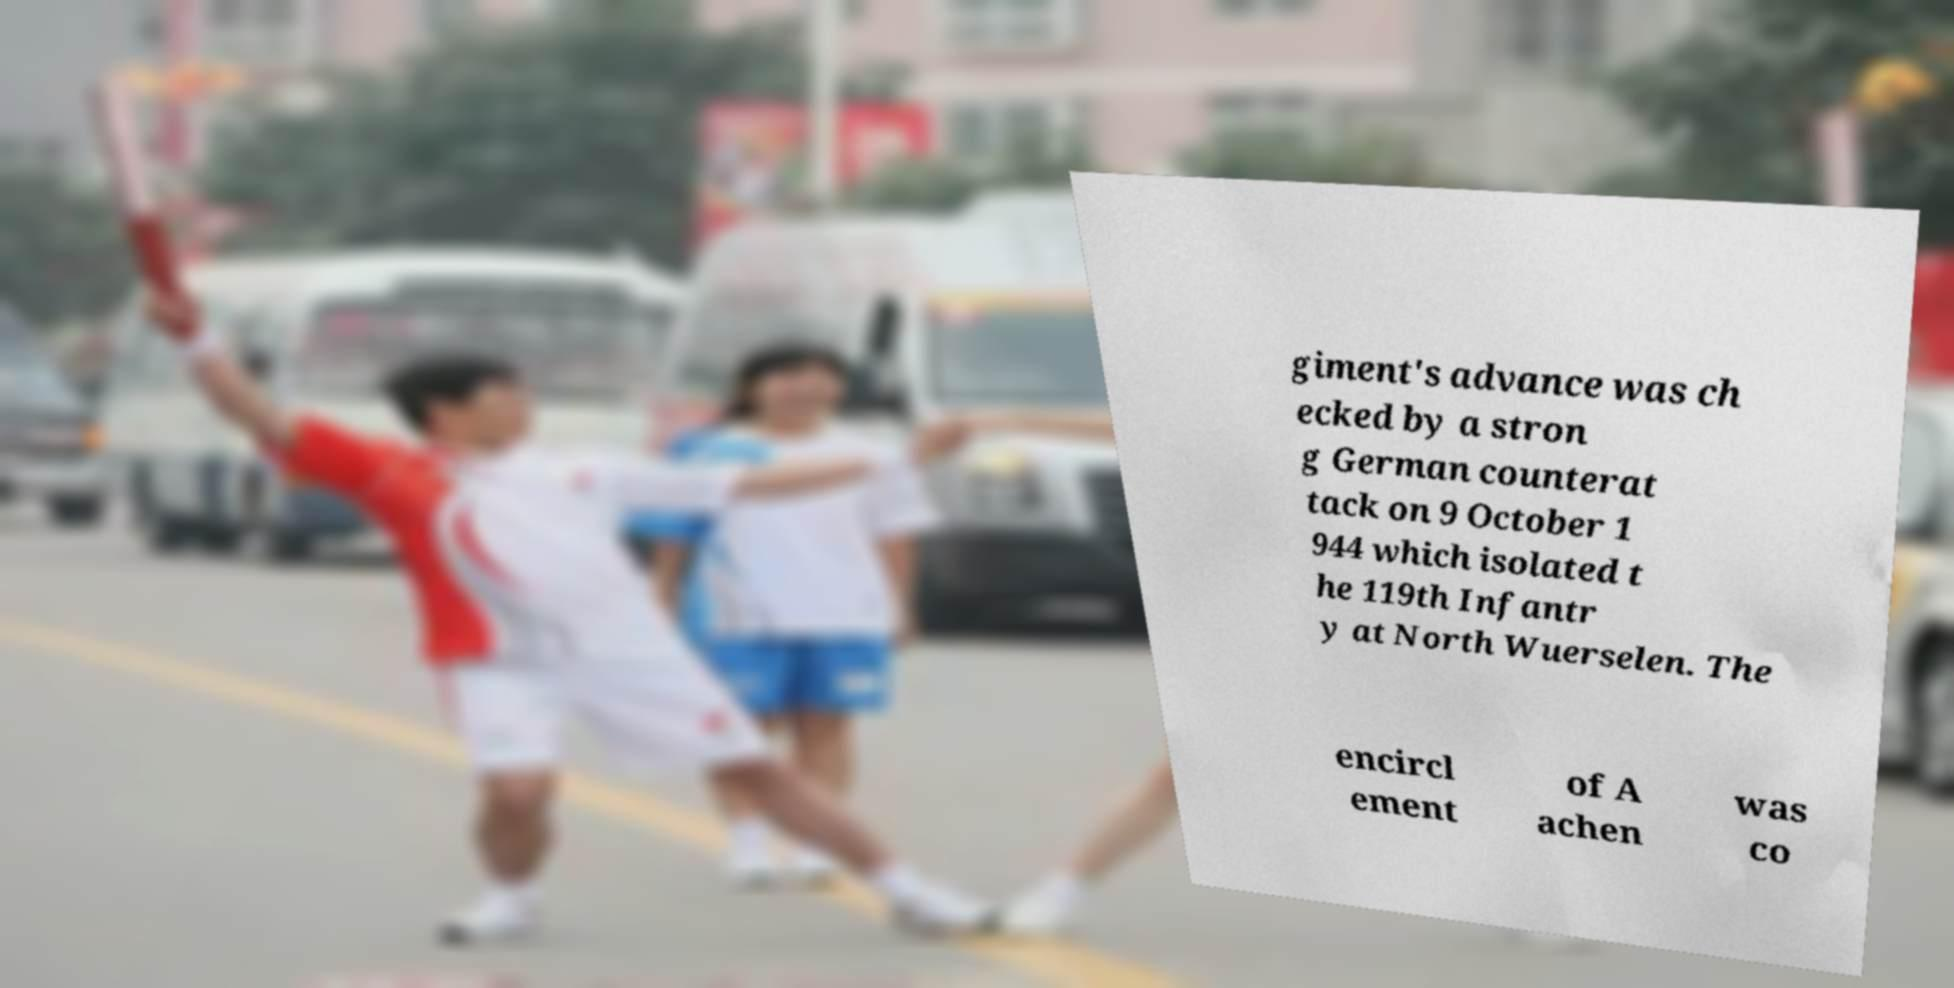Could you assist in decoding the text presented in this image and type it out clearly? giment's advance was ch ecked by a stron g German counterat tack on 9 October 1 944 which isolated t he 119th Infantr y at North Wuerselen. The encircl ement of A achen was co 